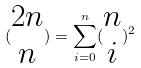Convert formula to latex. <formula><loc_0><loc_0><loc_500><loc_500>( \begin{matrix} 2 n \\ n \end{matrix} ) = \sum _ { i = 0 } ^ { n } ( \begin{matrix} n \\ i \end{matrix} ) ^ { 2 }</formula> 